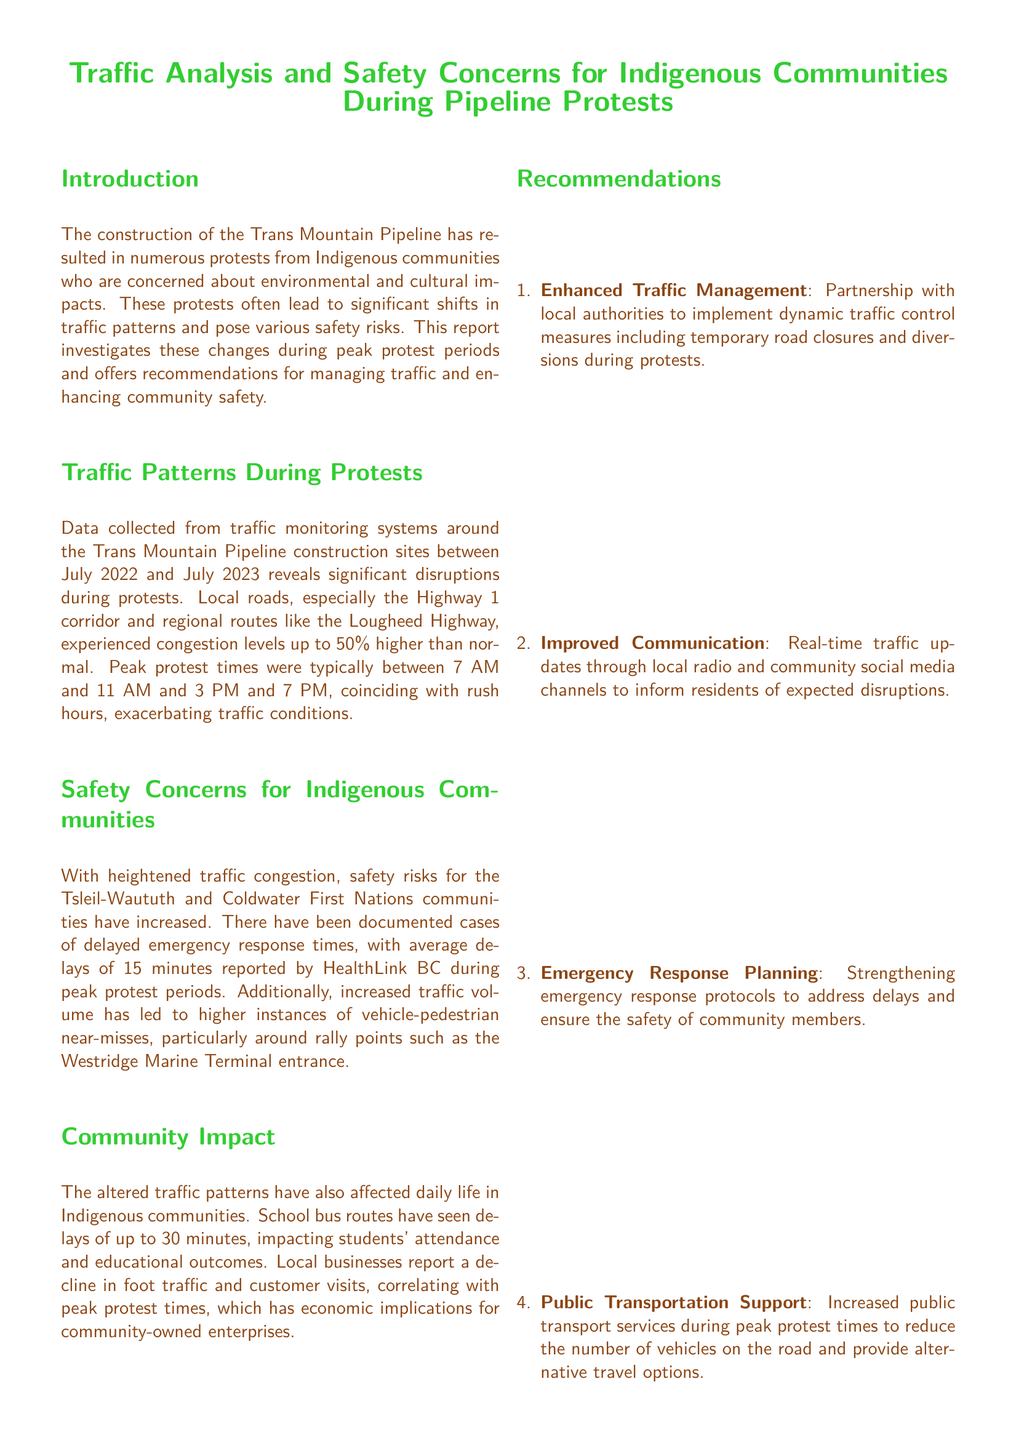What is the peak protest time in the morning? The peak protest times are specified as occurring between 7 AM and 11 AM.
Answer: 7 AM to 11 AM What is the percentage increase in congestion levels during protests? The report states that congestion levels were up to 50% higher than normal during protests.
Answer: 50% How long is the average delay reported for emergency responses? The average delays for emergency responses during peak protest periods are mentioned as 15 minutes.
Answer: 15 minutes What is the delay impact on school bus routes during protests? It is noted that school bus routes have seen delays of up to 30 minutes.
Answer: 30 minutes Which two Indigenous communities are mentioned as being affected? The report identifies the Tsleil-Waututh and Coldwater First Nations communities as affected by the traffic issues.
Answer: Tsleil-Waututh and Coldwater First Nations What type of communication is recommended for traffic updates? The document suggests the use of local radio and community social media channels for real-time traffic updates.
Answer: Local radio and community social media What kind of traffic control measures are recommended? Enhanced traffic management includes implementing dynamic traffic control measures like temporary road closures and diversions.
Answer: Dynamic traffic control measures What economic impact is mentioned for local businesses? The document mentions a decline in foot traffic and customer visits as an economic implication for community-owned enterprises.
Answer: Decline in foot traffic and customer visits 